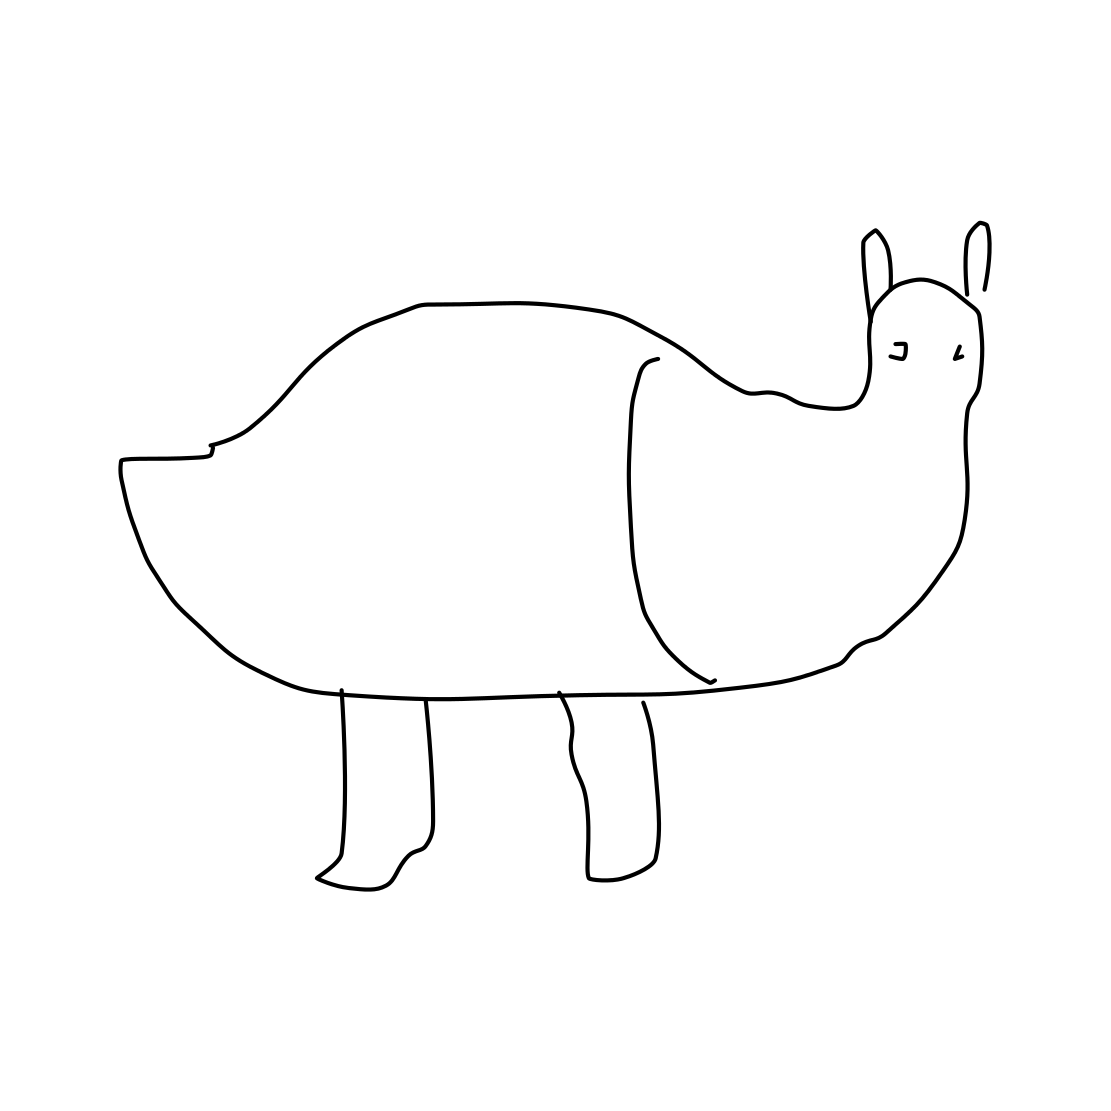Can you tell me what this drawing represents? The image appears to be a simplistic or abstract line drawing of an animal, though it is not immediately clear which animal it is meant to represent due to the lack of detail. It could be an imaginative creation or a very stylized depiction of a real animal. 